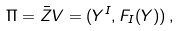<formula> <loc_0><loc_0><loc_500><loc_500>\Pi = \bar { Z } V = ( Y ^ { I } , F _ { I } ( Y ) ) \, ,</formula> 